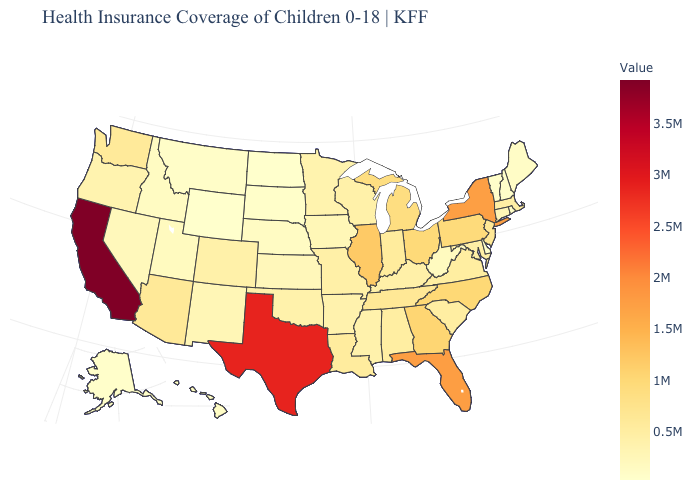Does California have the highest value in the West?
Answer briefly. Yes. Does Pennsylvania have a higher value than Wisconsin?
Short answer required. Yes. Among the states that border Illinois , which have the highest value?
Be succinct. Indiana. Does Nebraska have the highest value in the USA?
Be succinct. No. 